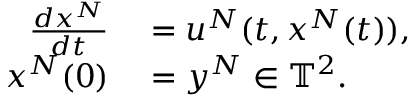Convert formula to latex. <formula><loc_0><loc_0><loc_500><loc_500>\begin{array} { r l } { \frac { d x ^ { N } } { d t } } & = u ^ { N } ( t , x ^ { N } ( t ) ) , } \\ { x ^ { N } ( 0 ) } & = y ^ { N } \in \mathbb { T } ^ { 2 } . } \end{array}</formula> 